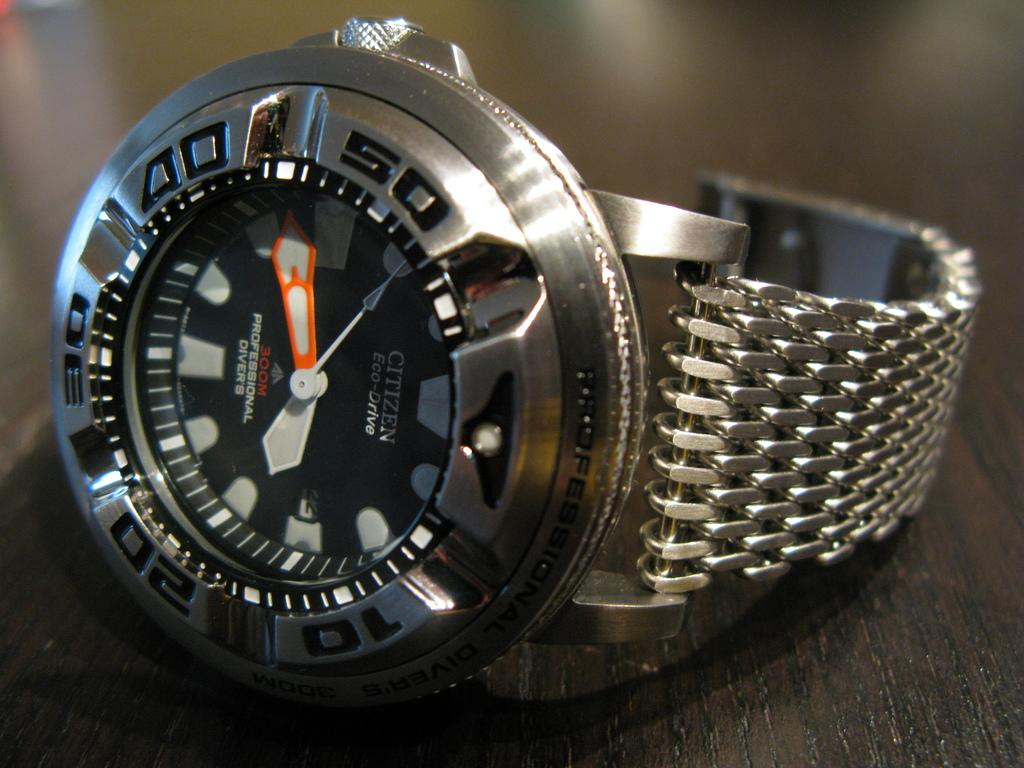What object is the main focus of the image? There is a watch in the image. Where is the watch placed? The watch is on a wooden surface. Can you describe the background of the image? The background of the image is blurred. What type of reaction can be seen from the passenger in the image? There is no passenger present in the image, as the main focus is on the watch. 